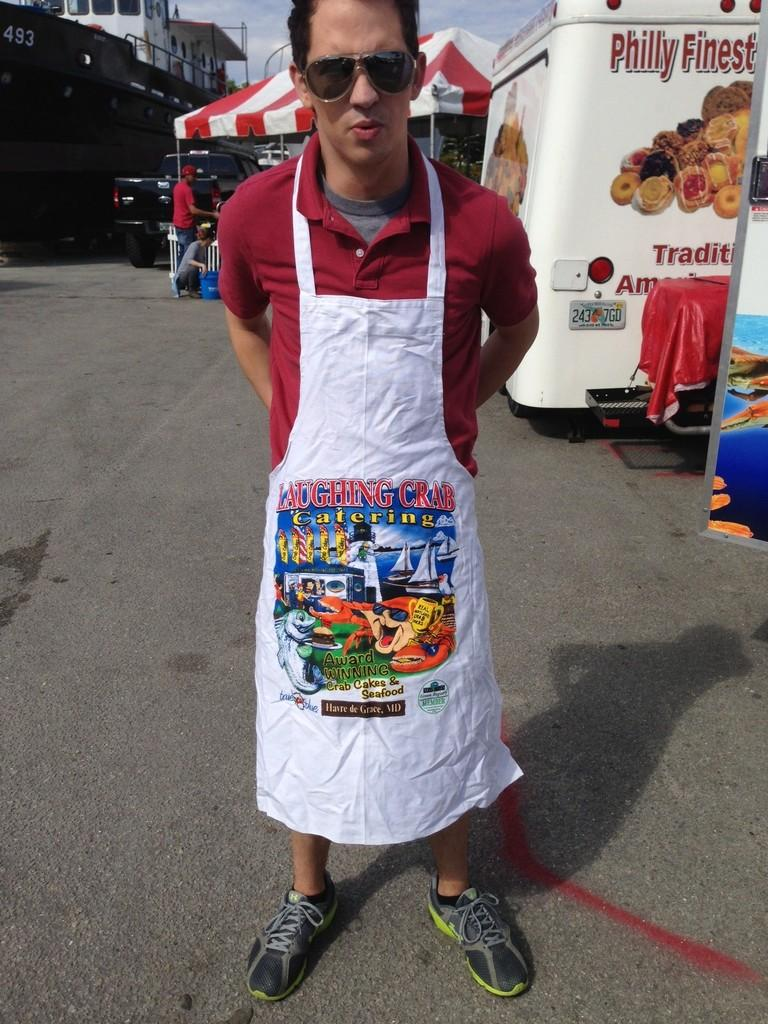<image>
Create a compact narrative representing the image presented. A man wearing a white apron with the words "Laughing Crab" written on it. 